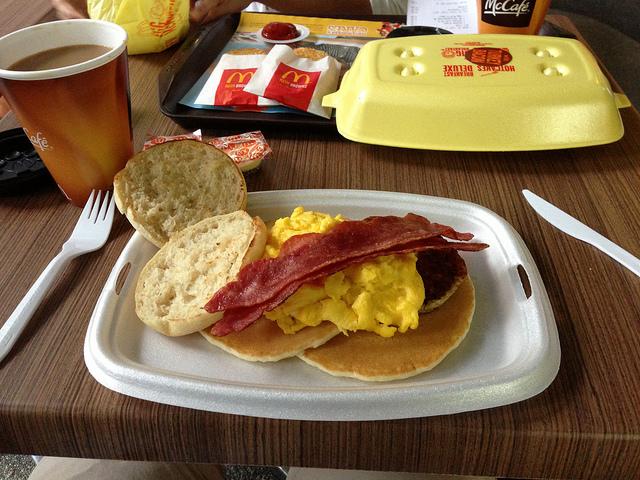Is there milk in the coffee?
Give a very brief answer. Yes. Are these scrambled eggs?
Keep it brief. Yes. What restaurant is this photo taken at?
Short answer required. Mcdonald's. 